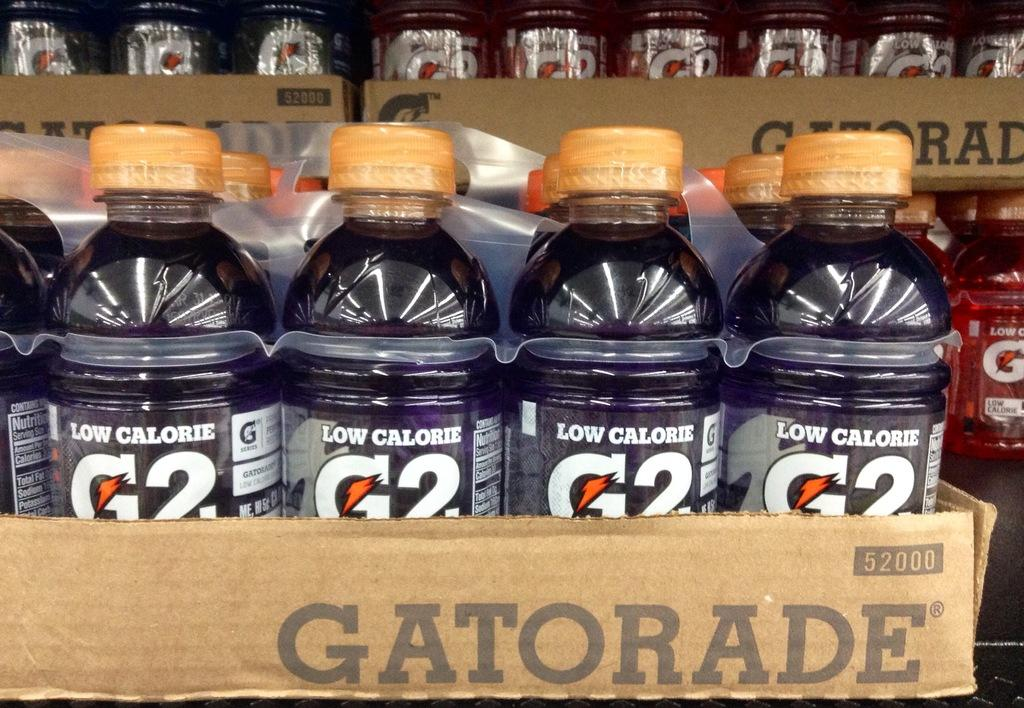What is the main subject of the image? The main subject of the image is a bunch of bottles. Where are the bottles located in the image? The bottles are in a box. What type of destruction can be seen happening to the goldfish in the image? There are no goldfish present in the image, so no destruction can be observed. 